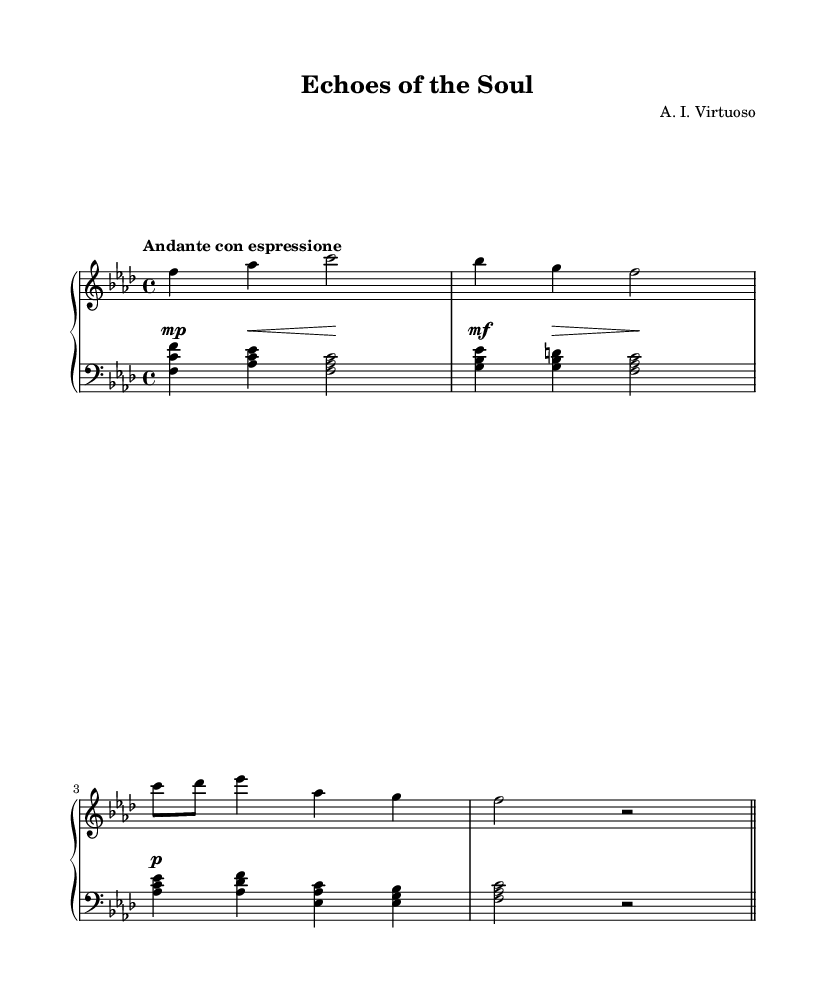What is the key signature of this music? The key signature shows three flats, which indicates that the piece is in F minor.
Answer: F minor What is the time signature of this music? The time signature is indicated at the beginning of the score as 4/4, meaning there are four beats in a measure, with a quarter note receiving one beat.
Answer: 4/4 What is the tempo marking for this piece? The tempo marking is found in the tempo indication and reads "Andante con espressione," which suggests a moderately slow pace with expression.
Answer: Andante con espressione How many measures are in the right-hand part? Counting the distinct groups of notes, there are four measures in the right-hand staff, as indicated by the placement of bar lines throughout the notation.
Answer: 4 What dynamic marking indicates a soft section in this music? In the music, the dynamics start with a "p" marking, which signifies soft playing, and this is one of the clear soft sections following the silence indicated by rests.
Answer: p Which section of the music is marked for a crescendo? The crescendo is notated with a hairpin going from a softer dynamic to a louder dynamic, indicated above the notes in the second measure. This means the players should gradually increase the volume during this phrasing.
Answer: crescendo 